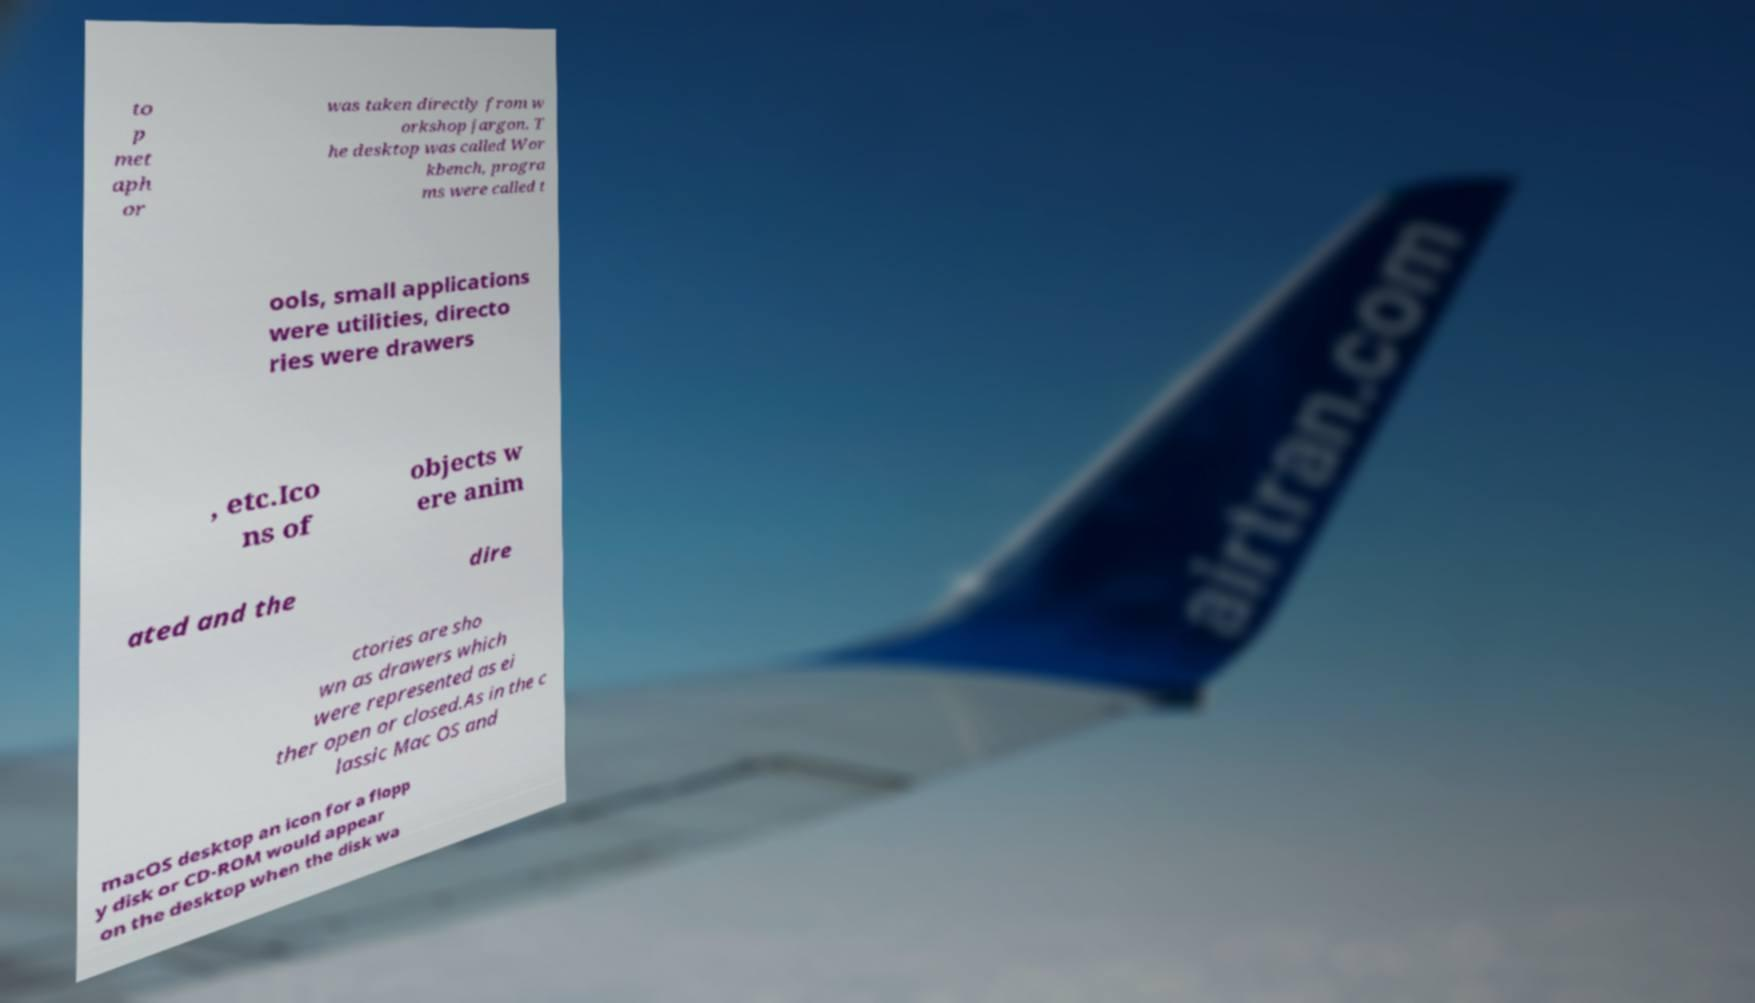Could you assist in decoding the text presented in this image and type it out clearly? to p met aph or was taken directly from w orkshop jargon. T he desktop was called Wor kbench, progra ms were called t ools, small applications were utilities, directo ries were drawers , etc.Ico ns of objects w ere anim ated and the dire ctories are sho wn as drawers which were represented as ei ther open or closed.As in the c lassic Mac OS and macOS desktop an icon for a flopp y disk or CD-ROM would appear on the desktop when the disk wa 